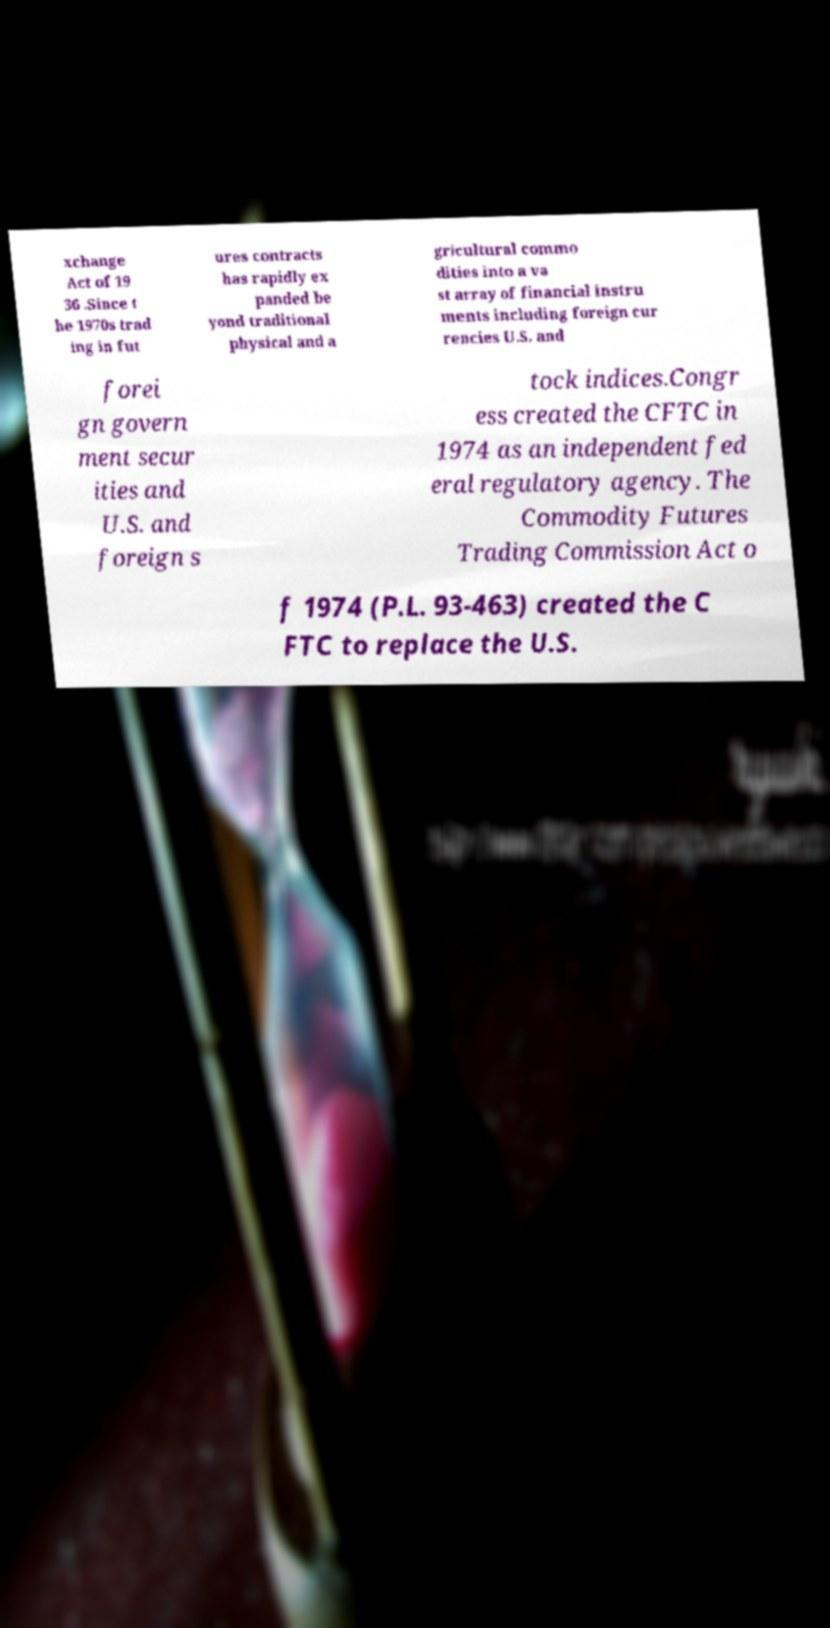Can you accurately transcribe the text from the provided image for me? xchange Act of 19 36 .Since t he 1970s trad ing in fut ures contracts has rapidly ex panded be yond traditional physical and a gricultural commo dities into a va st array of financial instru ments including foreign cur rencies U.S. and forei gn govern ment secur ities and U.S. and foreign s tock indices.Congr ess created the CFTC in 1974 as an independent fed eral regulatory agency. The Commodity Futures Trading Commission Act o f 1974 (P.L. 93-463) created the C FTC to replace the U.S. 